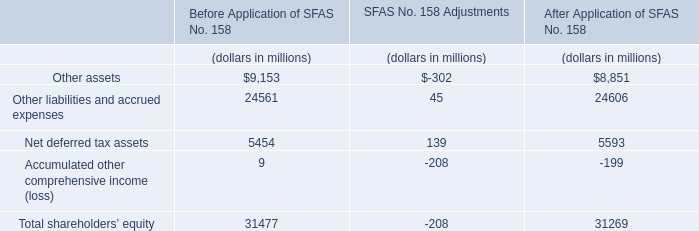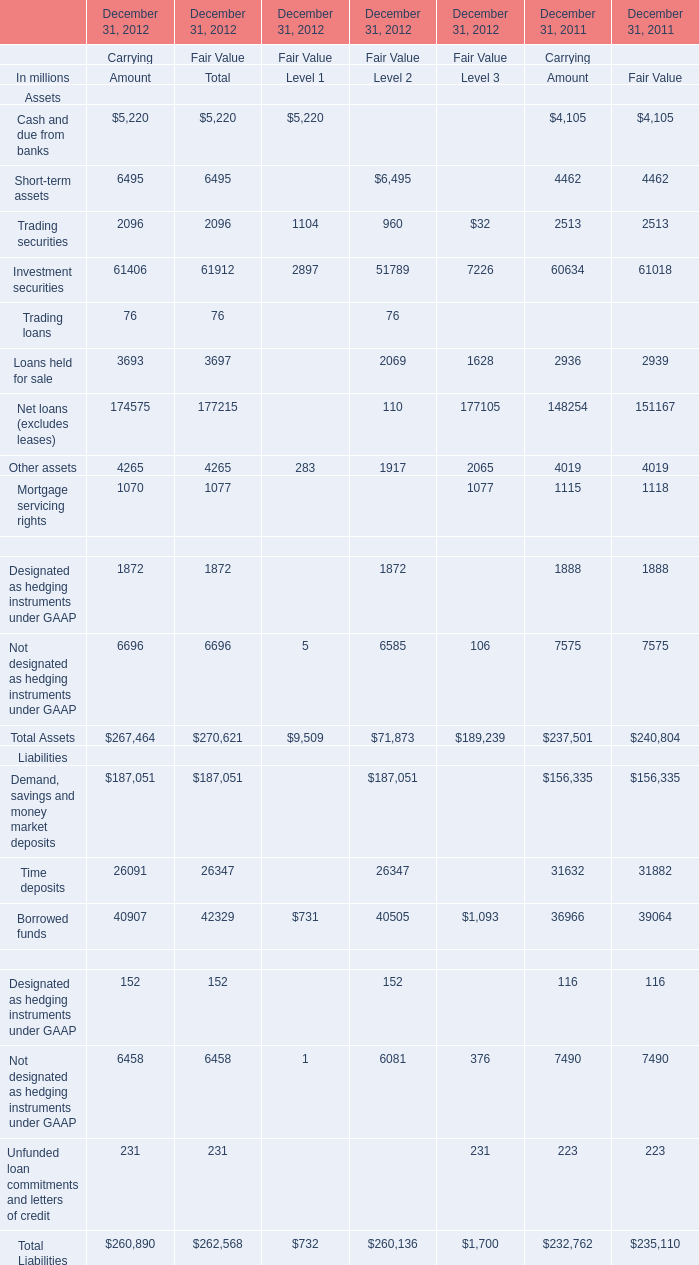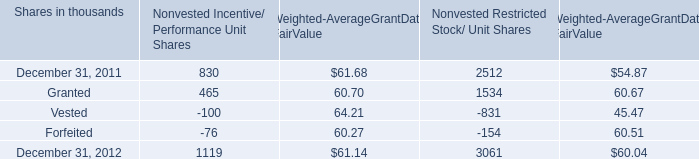what was the total weighted-average grant-date fair value of incentive/ performance unit share awards and restricted stock/unit awards granted in 2011 and 2010? 
Computations: (63.25 + 54.59)
Answer: 117.84. 